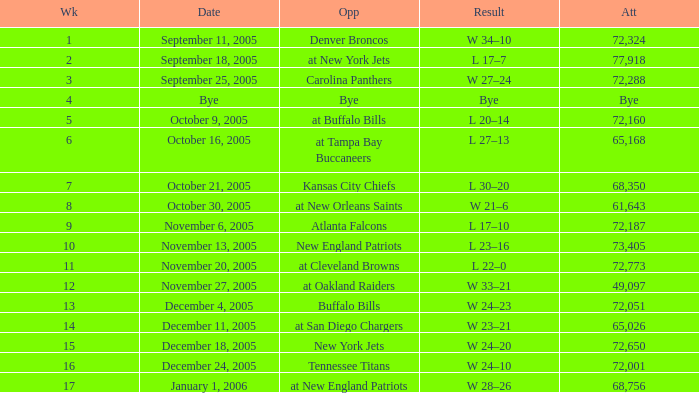In what week did the attendance reach 49,097? 12.0. Give me the full table as a dictionary. {'header': ['Wk', 'Date', 'Opp', 'Result', 'Att'], 'rows': [['1', 'September 11, 2005', 'Denver Broncos', 'W 34–10', '72,324'], ['2', 'September 18, 2005', 'at New York Jets', 'L 17–7', '77,918'], ['3', 'September 25, 2005', 'Carolina Panthers', 'W 27–24', '72,288'], ['4', 'Bye', 'Bye', 'Bye', 'Bye'], ['5', 'October 9, 2005', 'at Buffalo Bills', 'L 20–14', '72,160'], ['6', 'October 16, 2005', 'at Tampa Bay Buccaneers', 'L 27–13', '65,168'], ['7', 'October 21, 2005', 'Kansas City Chiefs', 'L 30–20', '68,350'], ['8', 'October 30, 2005', 'at New Orleans Saints', 'W 21–6', '61,643'], ['9', 'November 6, 2005', 'Atlanta Falcons', 'L 17–10', '72,187'], ['10', 'November 13, 2005', 'New England Patriots', 'L 23–16', '73,405'], ['11', 'November 20, 2005', 'at Cleveland Browns', 'L 22–0', '72,773'], ['12', 'November 27, 2005', 'at Oakland Raiders', 'W 33–21', '49,097'], ['13', 'December 4, 2005', 'Buffalo Bills', 'W 24–23', '72,051'], ['14', 'December 11, 2005', 'at San Diego Chargers', 'W 23–21', '65,026'], ['15', 'December 18, 2005', 'New York Jets', 'W 24–20', '72,650'], ['16', 'December 24, 2005', 'Tennessee Titans', 'W 24–10', '72,001'], ['17', 'January 1, 2006', 'at New England Patriots', 'W 28–26', '68,756']]} 